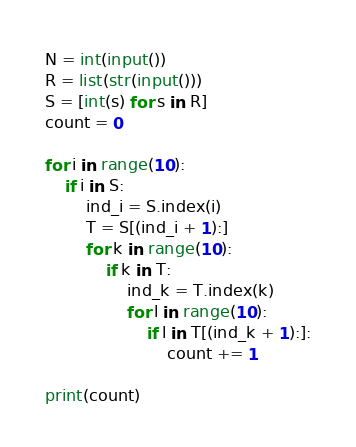<code> <loc_0><loc_0><loc_500><loc_500><_Python_>N = int(input())
R = list(str(input()))
S = [int(s) for s in R]
count = 0

for i in range(10):
    if i in S:
        ind_i = S.index(i)
        T = S[(ind_i + 1):]
        for k in range(10):
            if k in T:
                ind_k = T.index(k)
                for l in range(10):
                    if l in T[(ind_k + 1):]:
                        count += 1

print(count)</code> 